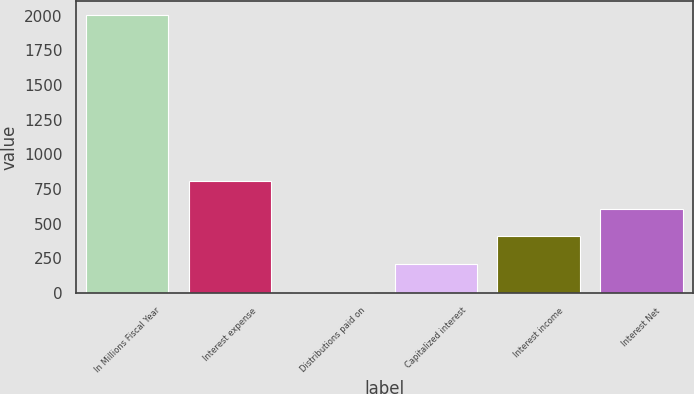<chart> <loc_0><loc_0><loc_500><loc_500><bar_chart><fcel>In Millions Fiscal Year<fcel>Interest expense<fcel>Distributions paid on<fcel>Capitalized interest<fcel>Interest income<fcel>Interest Net<nl><fcel>2004<fcel>806.4<fcel>8<fcel>207.6<fcel>407.2<fcel>606.8<nl></chart> 